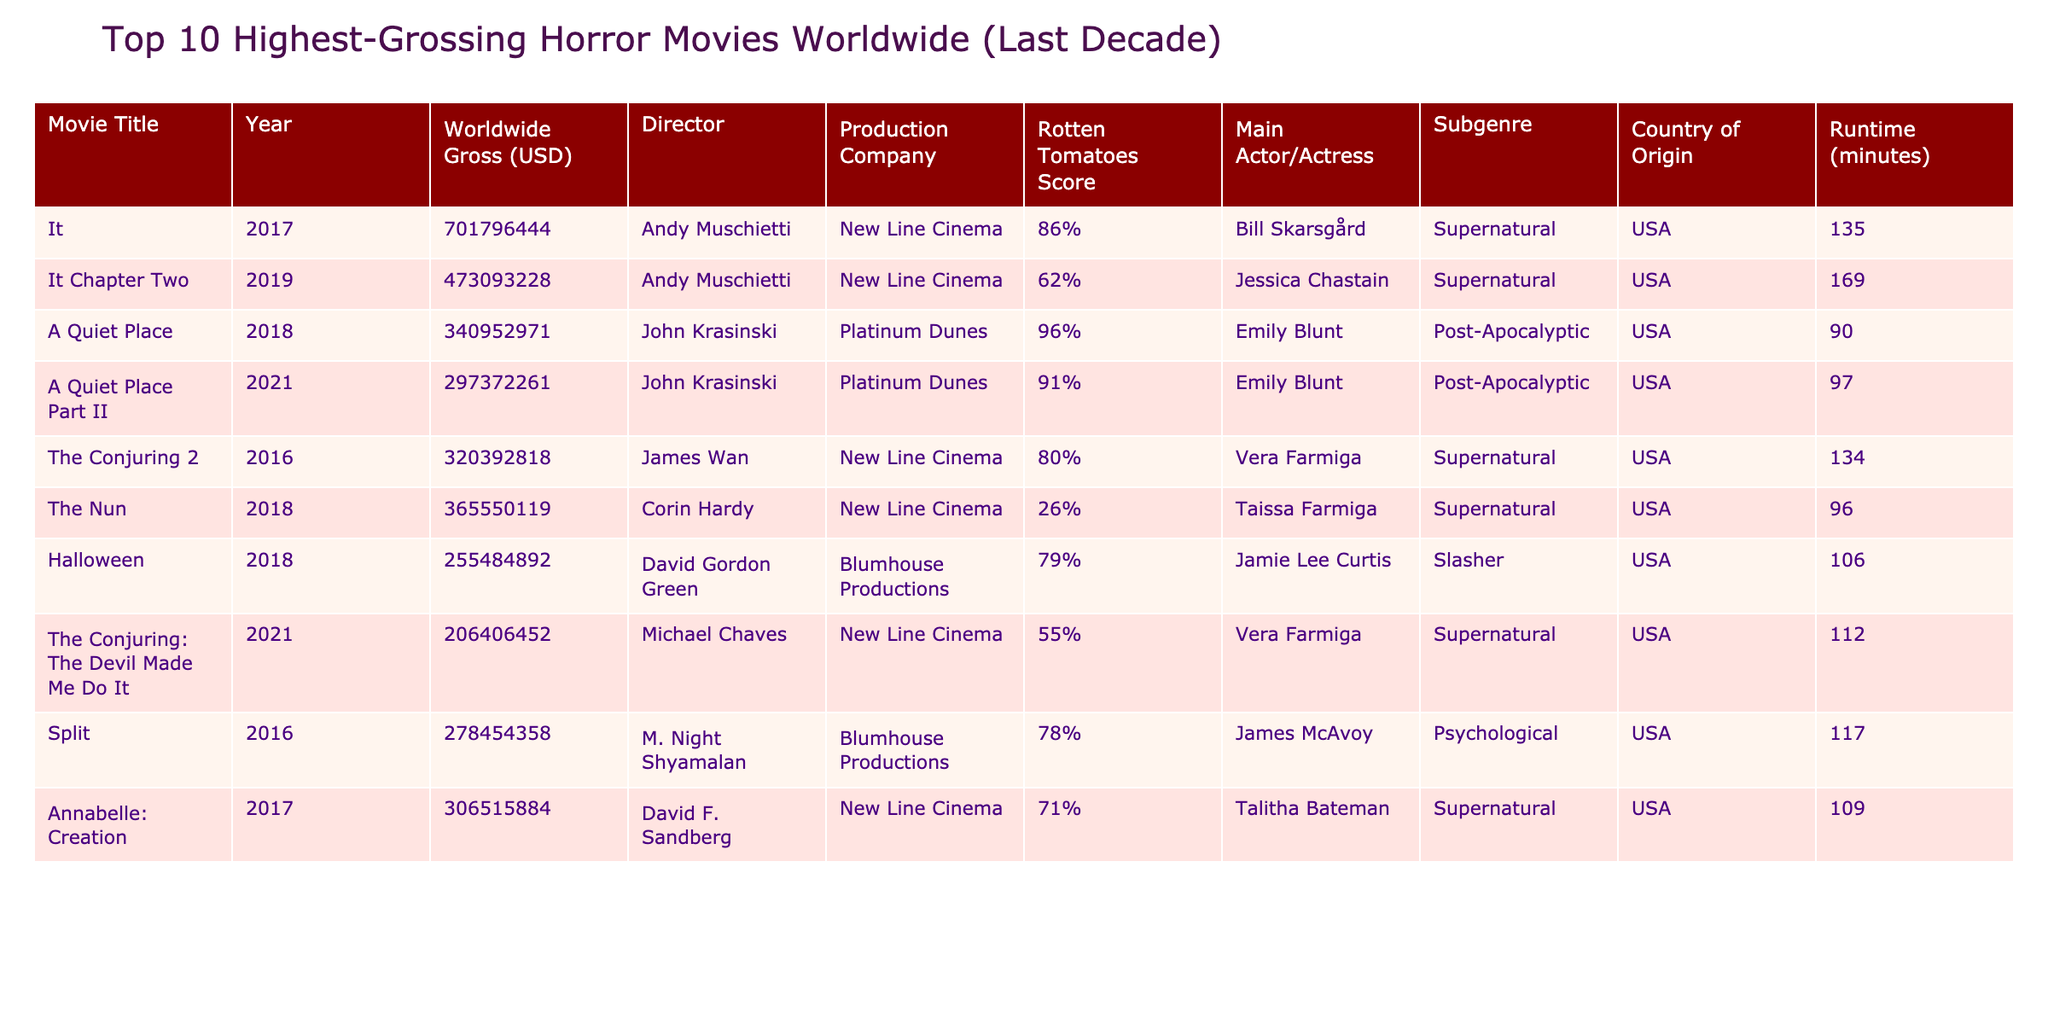What is the highest-grossing horror movie in the last decade? The table shows that 'It' from 2017 has the highest worldwide gross of $701,796,444.
Answer: It Which movie has the lowest Rotten Tomatoes score? The Nun, released in 2018, has the lowest Rotten Tomatoes score at 26%.
Answer: The Nun How much did A Quiet Place Part II earn worldwide? According to the table, A Quiet Place Part II earned $297,372,261 worldwide.
Answer: $297,372,261 What is the average worldwide gross of the top 10 movies listed? The total worldwide gross of the 10 movies is $2,985,250,150. Dividing this by 10 gives an average of $298,525,015.
Answer: $298,525,015 How many movies in the table are directed by Andy Muschietti? There are 2 movies by Andy Muschietti: 'It' and 'It Chapter Two'.
Answer: 2 Did any movie released in 2021 make it to the top 10? Yes, both A Quiet Place Part II and The Conjuring: The Devil Made Me Do It were released in 2021 and are in the top 10.
Answer: Yes Which subgenre has the most films listed in this table? The 'Supernatural' subgenre has the most films, with 5 titles in the list.
Answer: Supernatural What is the total runtime of all movies directed by John Krasinski? The runtimes for A Quiet Place and A Quiet Place Part II are 90 minutes and 97 minutes, respectively. Adding these gives a total of 187 minutes.
Answer: 187 minutes Is there a movie among the top 10 that has a Rotten Tomatoes score above 90%? Yes, A Quiet Place has a Rotten Tomatoes score of 96%, which is above 90%.
Answer: Yes Which country produced the most movies in this table? All listed movies originate from the USA, indicating that the USA produced the most movies in the table.
Answer: USA 